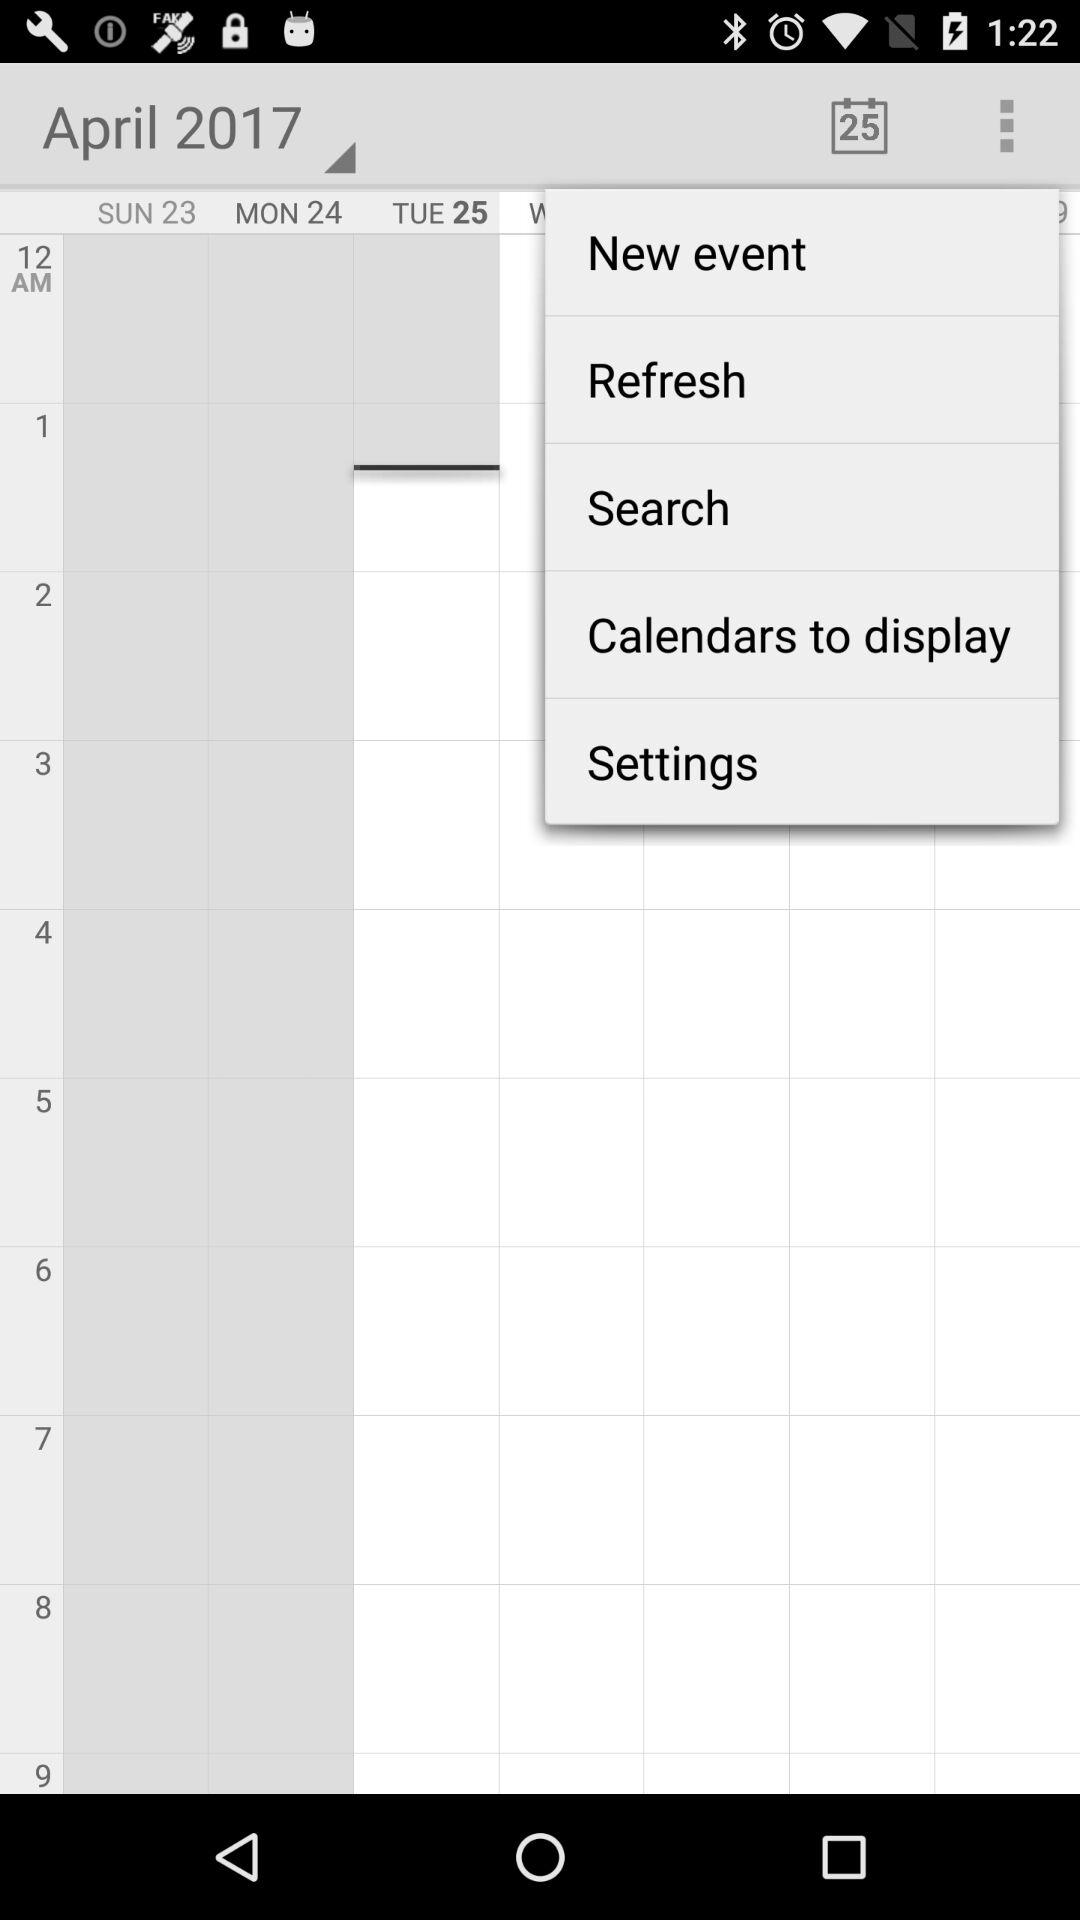What day falls on April 25, 2017? The day is Tuesday. 